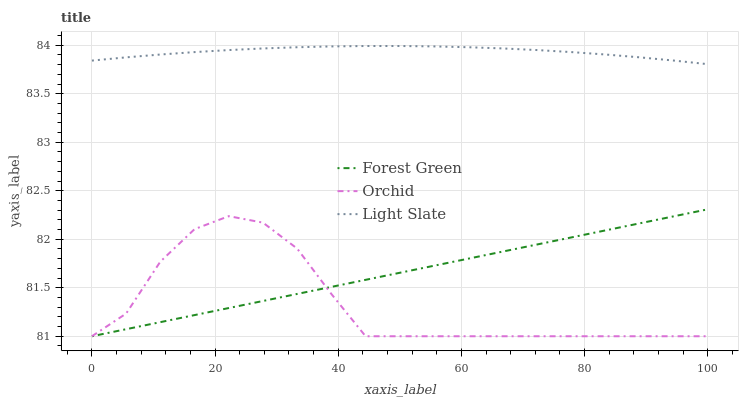Does Orchid have the minimum area under the curve?
Answer yes or no. Yes. Does Light Slate have the maximum area under the curve?
Answer yes or no. Yes. Does Forest Green have the minimum area under the curve?
Answer yes or no. No. Does Forest Green have the maximum area under the curve?
Answer yes or no. No. Is Forest Green the smoothest?
Answer yes or no. Yes. Is Orchid the roughest?
Answer yes or no. Yes. Is Orchid the smoothest?
Answer yes or no. No. Is Forest Green the roughest?
Answer yes or no. No. Does Light Slate have the highest value?
Answer yes or no. Yes. Does Forest Green have the highest value?
Answer yes or no. No. Is Orchid less than Light Slate?
Answer yes or no. Yes. Is Light Slate greater than Orchid?
Answer yes or no. Yes. Does Orchid intersect Forest Green?
Answer yes or no. Yes. Is Orchid less than Forest Green?
Answer yes or no. No. Is Orchid greater than Forest Green?
Answer yes or no. No. Does Orchid intersect Light Slate?
Answer yes or no. No. 